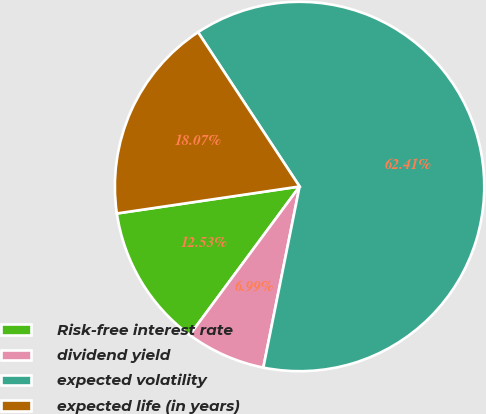Convert chart to OTSL. <chart><loc_0><loc_0><loc_500><loc_500><pie_chart><fcel>Risk-free interest rate<fcel>dividend yield<fcel>expected volatility<fcel>expected life (in years)<nl><fcel>12.53%<fcel>6.99%<fcel>62.41%<fcel>18.07%<nl></chart> 